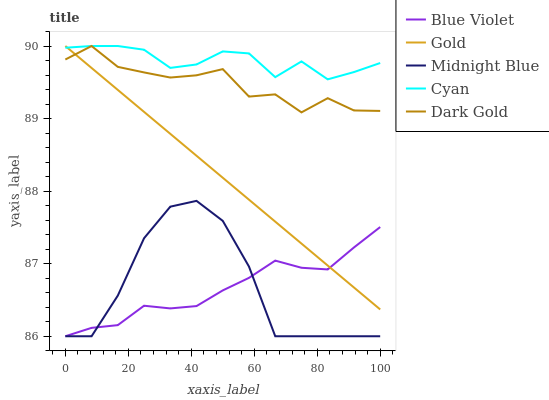Does Blue Violet have the minimum area under the curve?
Answer yes or no. Yes. Does Cyan have the maximum area under the curve?
Answer yes or no. Yes. Does Dark Gold have the minimum area under the curve?
Answer yes or no. No. Does Dark Gold have the maximum area under the curve?
Answer yes or no. No. Is Gold the smoothest?
Answer yes or no. Yes. Is Midnight Blue the roughest?
Answer yes or no. Yes. Is Dark Gold the smoothest?
Answer yes or no. No. Is Dark Gold the roughest?
Answer yes or no. No. Does Blue Violet have the lowest value?
Answer yes or no. Yes. Does Dark Gold have the lowest value?
Answer yes or no. No. Does Gold have the highest value?
Answer yes or no. Yes. Does Blue Violet have the highest value?
Answer yes or no. No. Is Midnight Blue less than Dark Gold?
Answer yes or no. Yes. Is Cyan greater than Midnight Blue?
Answer yes or no. Yes. Does Dark Gold intersect Gold?
Answer yes or no. Yes. Is Dark Gold less than Gold?
Answer yes or no. No. Is Dark Gold greater than Gold?
Answer yes or no. No. Does Midnight Blue intersect Dark Gold?
Answer yes or no. No. 